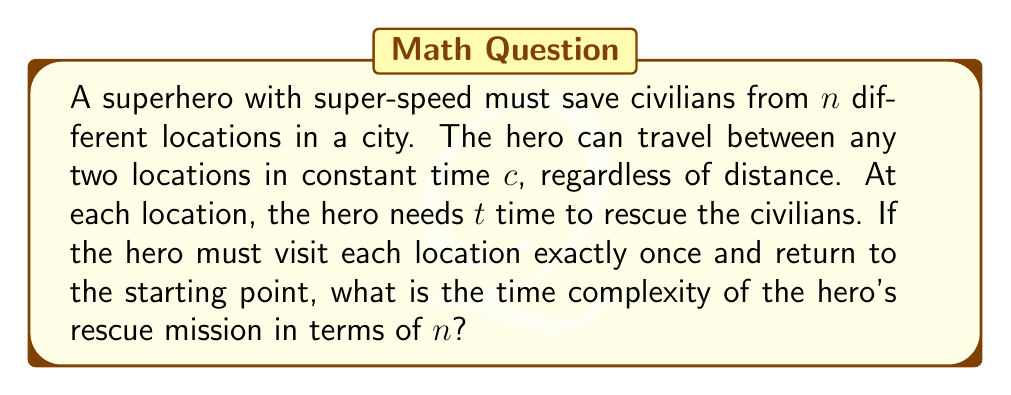Show me your answer to this math problem. Let's analyze this problem step by step:

1) First, we need to recognize that this problem is similar to the Traveling Salesman Problem (TSP), where the superhero needs to visit each location once and return to the starting point.

2) The time taken for travel between locations:
   - There are $n+1$ travels (including the return to start)
   - Each travel takes constant time $c$
   - Total travel time: $(n+1)c$

3) The time taken for rescuing civilians:
   - The hero visits $n$ locations
   - At each location, the rescue takes time $t$
   - Total rescue time: $nt$

4) Total time for the mission: $T(n) = (n+1)c + nt$

5) In terms of asymptotic notation:
   $T(n) = O(n)$

   This is because both components of the time function grow linearly with $n$.

6) However, this assumes that the hero knows the optimal path to visit all locations. Finding this optimal path is equivalent to solving the TSP, which is NP-hard.

7) If we include the time to compute the optimal path, the overall time complexity becomes:
   $O(n!) + O(n) = O(n!)$

   This is because the best known exact algorithm for TSP runs in $O(n!)$ time.

Therefore, while the actual rescue mission takes linear time, the overall problem including path optimization has factorial time complexity.
Answer: The time complexity of the superhero's rescue mission, including path optimization, is $O(n!)$, where $n$ is the number of locations to be visited. 